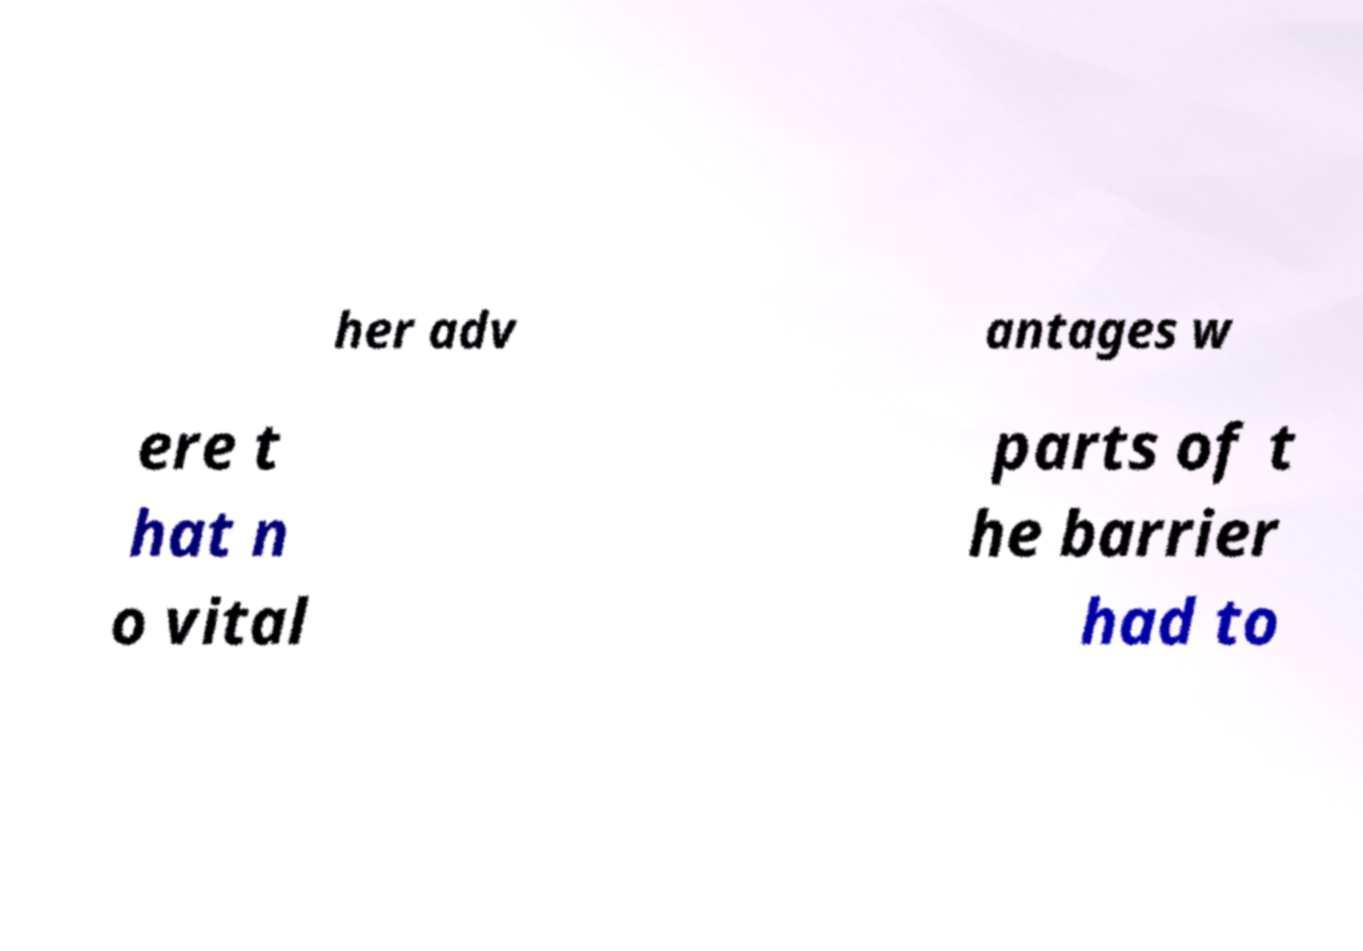I need the written content from this picture converted into text. Can you do that? her adv antages w ere t hat n o vital parts of t he barrier had to 